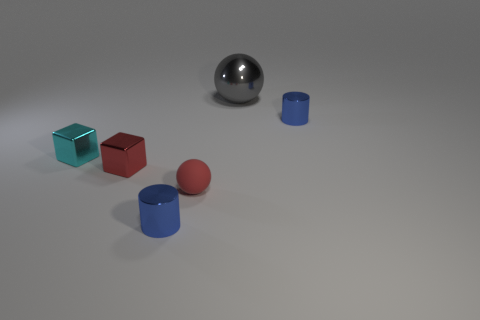Subtract 1 blocks. How many blocks are left? 1 Add 2 big metallic things. How many objects exist? 8 Subtract all blocks. How many objects are left? 4 Subtract all tiny red matte spheres. Subtract all cylinders. How many objects are left? 3 Add 1 tiny rubber objects. How many tiny rubber objects are left? 2 Add 3 gray things. How many gray things exist? 4 Subtract 0 blue balls. How many objects are left? 6 Subtract all purple spheres. Subtract all blue blocks. How many spheres are left? 2 Subtract all cyan blocks. How many brown spheres are left? 0 